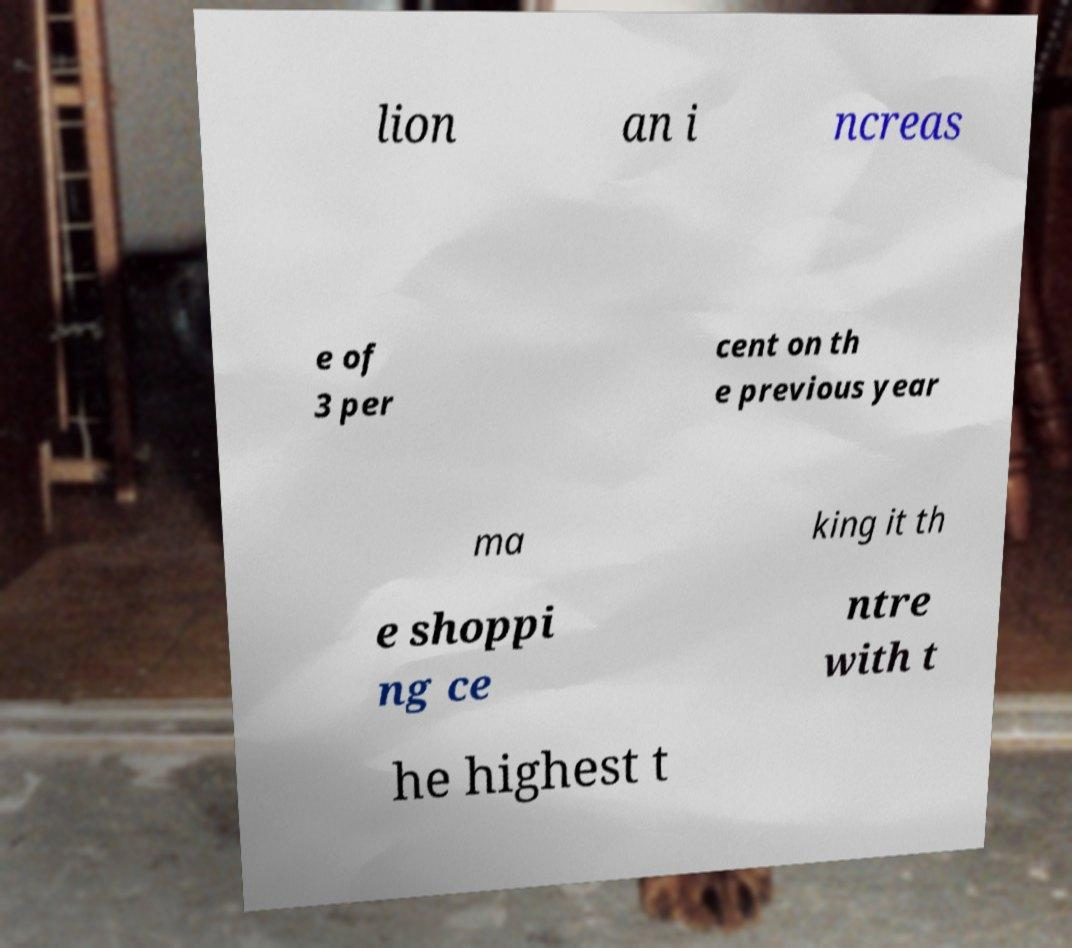Could you assist in decoding the text presented in this image and type it out clearly? lion an i ncreas e of 3 per cent on th e previous year ma king it th e shoppi ng ce ntre with t he highest t 